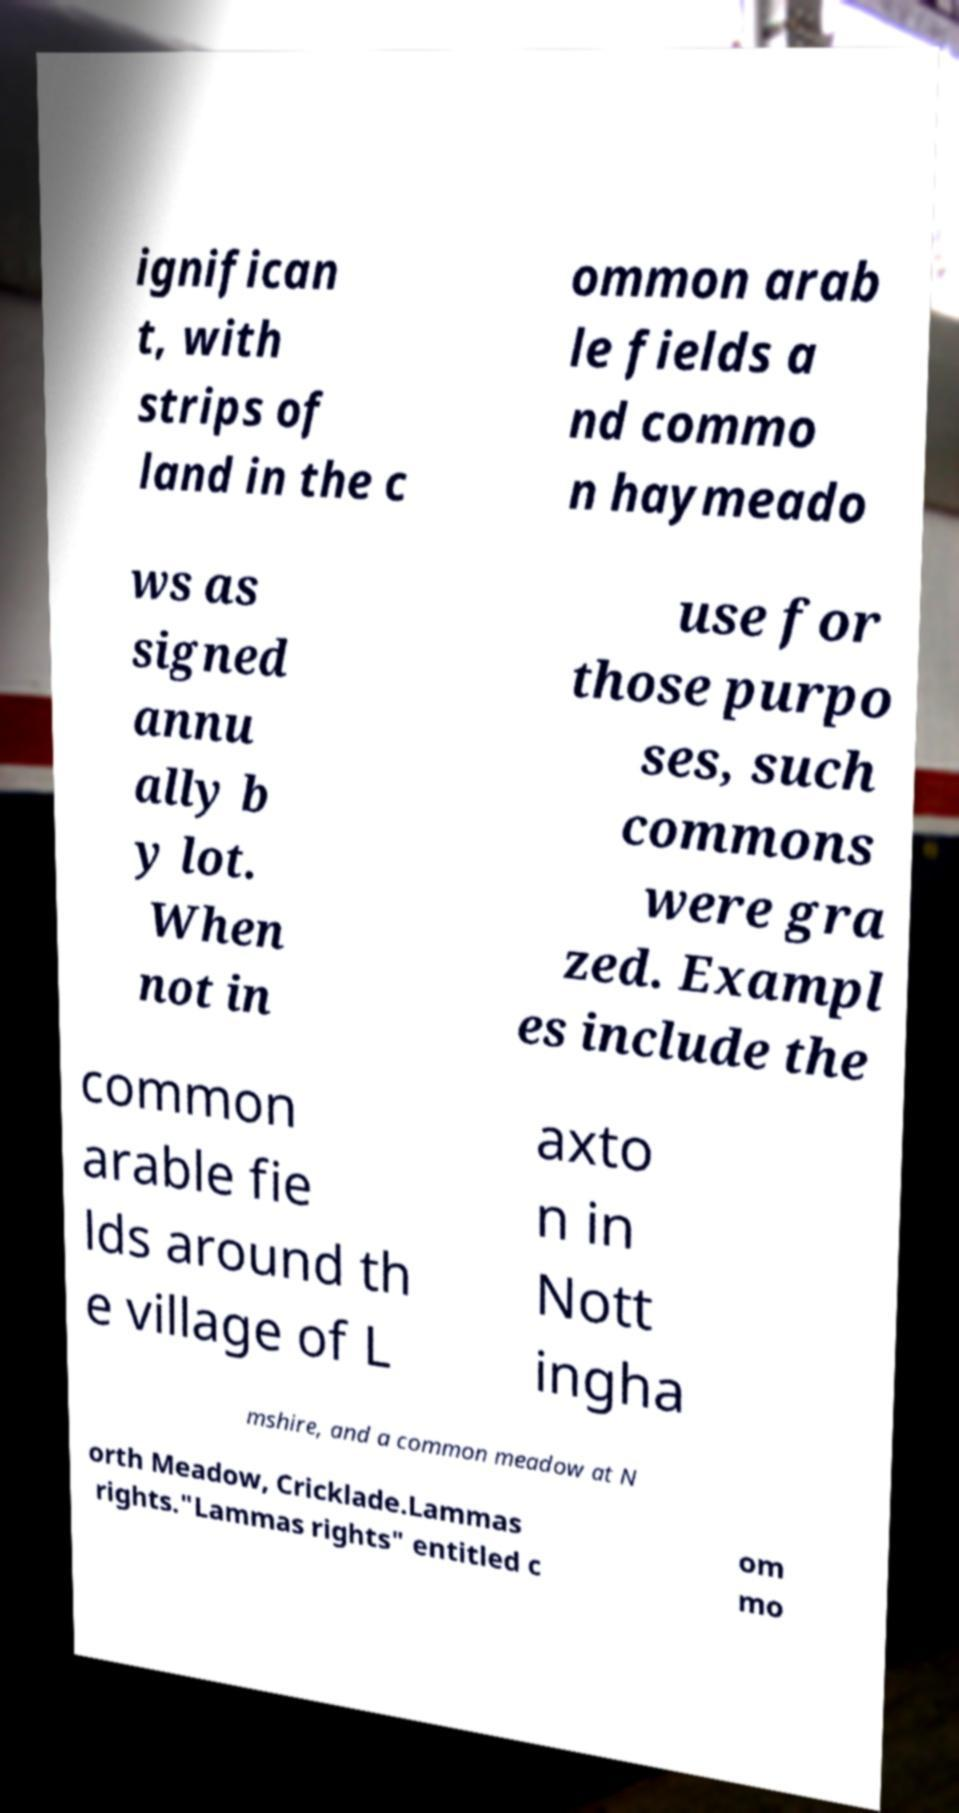Please identify and transcribe the text found in this image. ignifican t, with strips of land in the c ommon arab le fields a nd commo n haymeado ws as signed annu ally b y lot. When not in use for those purpo ses, such commons were gra zed. Exampl es include the common arable fie lds around th e village of L axto n in Nott ingha mshire, and a common meadow at N orth Meadow, Cricklade.Lammas rights."Lammas rights" entitled c om mo 